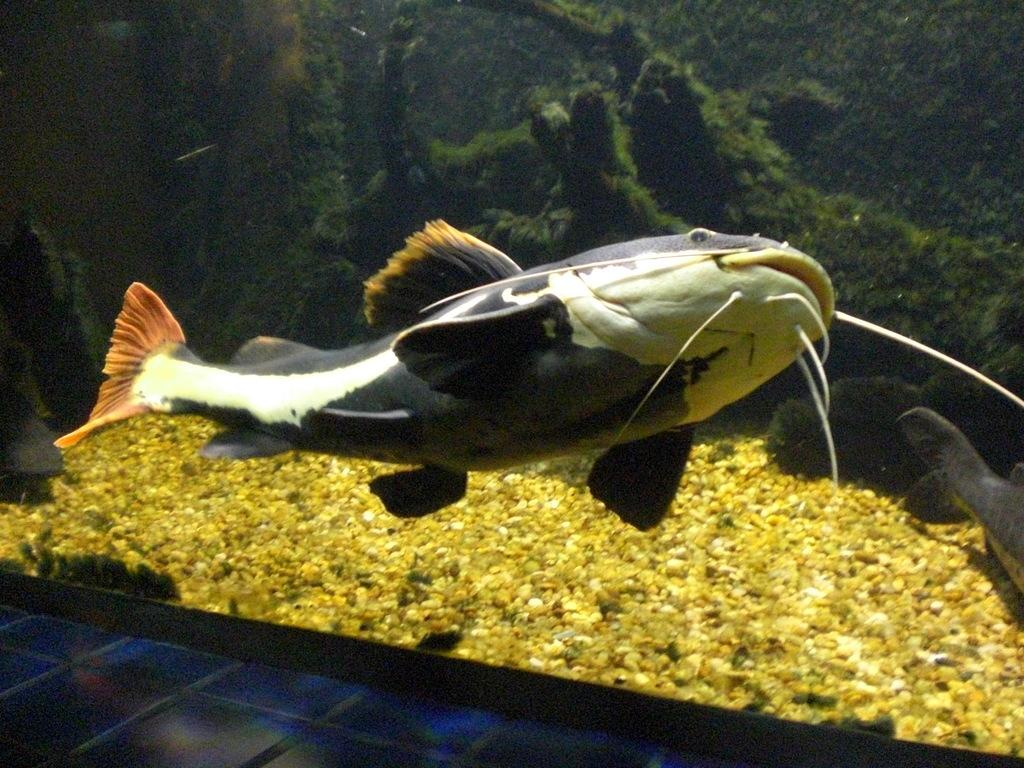What is the main subject in the center of the image? There is a big fish in the center of the image. Are there any other fish visible in the image? Yes, there is another fish on the right side of the image. What can be found inside the aquarium besides the fish? There are pebbles and plants inside the aquarium. What color is the hope that is visible in the image? There is no hope present in the image; it is a photograph of fish in an aquarium. 